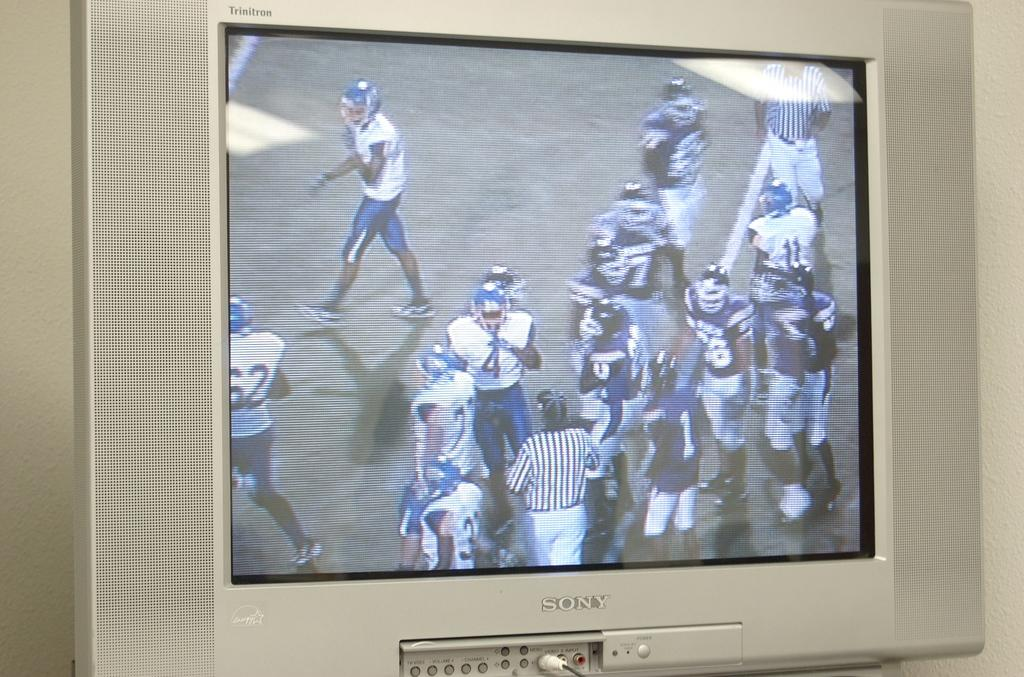Provide a one-sentence caption for the provided image. Silver sony television with video input and menu buttons. 